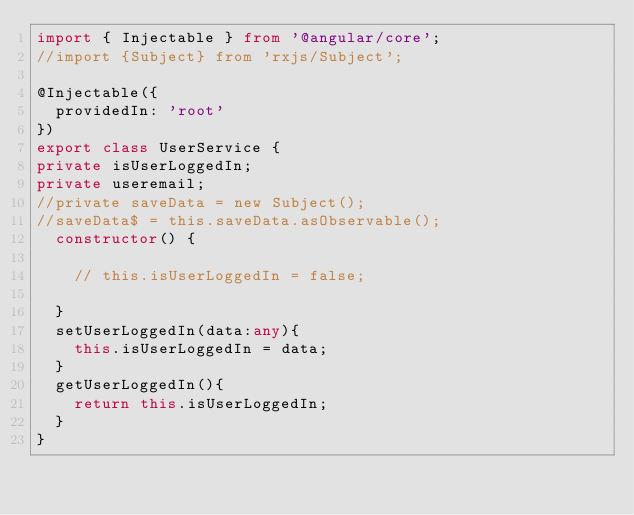<code> <loc_0><loc_0><loc_500><loc_500><_TypeScript_>import { Injectable } from '@angular/core';
//import {Subject} from 'rxjs/Subject';

@Injectable({
  providedIn: 'root'
})
export class UserService {
private isUserLoggedIn;
private useremail;
//private saveData = new Subject();
//saveData$ = this.saveData.asObservable();
  constructor() { 
    
    // this.isUserLoggedIn = false;

  }
  setUserLoggedIn(data:any){
    this.isUserLoggedIn = data;
  }
  getUserLoggedIn(){
    return this.isUserLoggedIn;
  }
}
</code> 